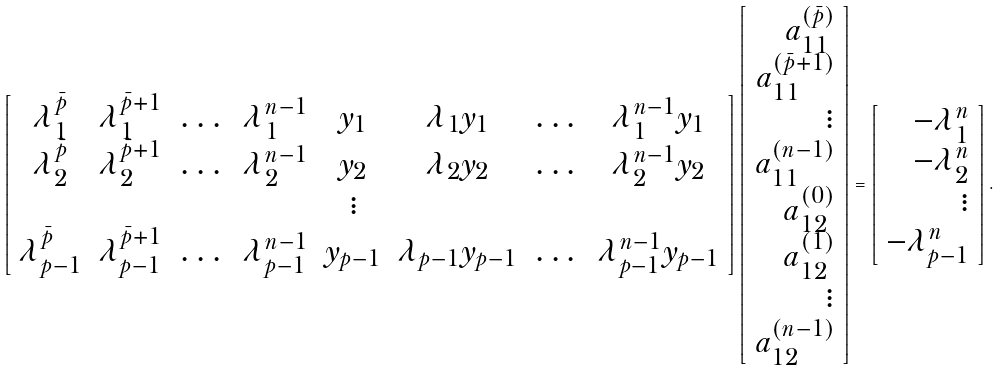<formula> <loc_0><loc_0><loc_500><loc_500>\left [ \begin{array} { c c c c c c c c } \lambda _ { 1 } ^ { \bar { p } } & \lambda _ { 1 } ^ { \bar { p } + 1 } & \dots & \lambda _ { 1 } ^ { n - 1 } & y _ { 1 } & \lambda _ { 1 } y _ { 1 } & \dots & \lambda _ { 1 } ^ { n - 1 } y _ { 1 } \\ \lambda _ { 2 } ^ { \bar { p } } & \lambda _ { 2 } ^ { \bar { p } + 1 } & \dots & \lambda _ { 2 } ^ { n - 1 } & y _ { 2 } & \lambda _ { 2 } y _ { 2 } & \dots & \lambda _ { 2 } ^ { n - 1 } y _ { 2 } \\ & & & & \vdots & & & \\ \lambda _ { p - 1 } ^ { \bar { p } } & \lambda _ { p - 1 } ^ { \bar { p } + 1 } & \dots & \lambda _ { p - 1 } ^ { n - 1 } & y _ { p - 1 } & \lambda _ { p - 1 } y _ { p - 1 } & \dots & \lambda _ { p - 1 } ^ { n - 1 } y _ { p - 1 } \\ \end{array} \right ] \left [ \begin{array} { r } a _ { 1 1 } ^ { ( \bar { p } ) } \\ a _ { 1 1 } ^ { ( \bar { p } + 1 ) } \\ \vdots \\ a _ { 1 1 } ^ { ( n - 1 ) } \\ a _ { 1 2 } ^ { ( 0 ) } \\ a _ { 1 2 } ^ { ( 1 ) } \\ \vdots \\ a _ { 1 2 } ^ { ( n - 1 ) } \end{array} \right ] = \left [ \begin{array} { r } - \lambda _ { 1 } ^ { n } \\ - \lambda _ { 2 } ^ { n } \\ \vdots \\ - \lambda _ { p - 1 } ^ { n } \end{array} \right ] .</formula> 